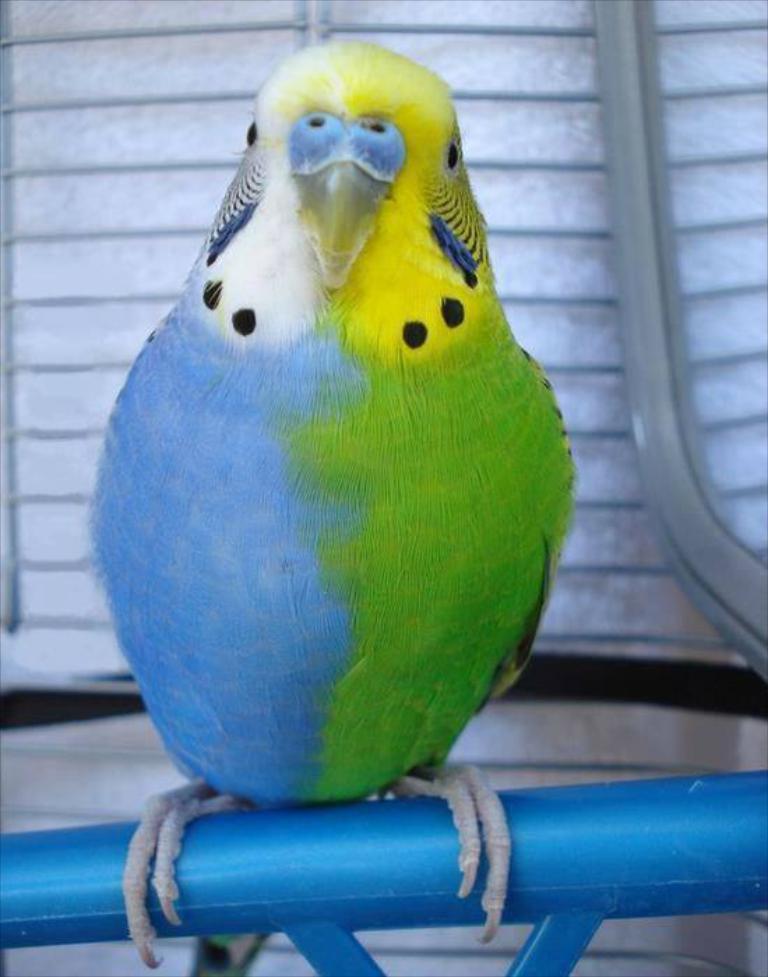In one or two sentences, can you explain what this image depicts? In the image there is a colorful parrot standing on blue road. 